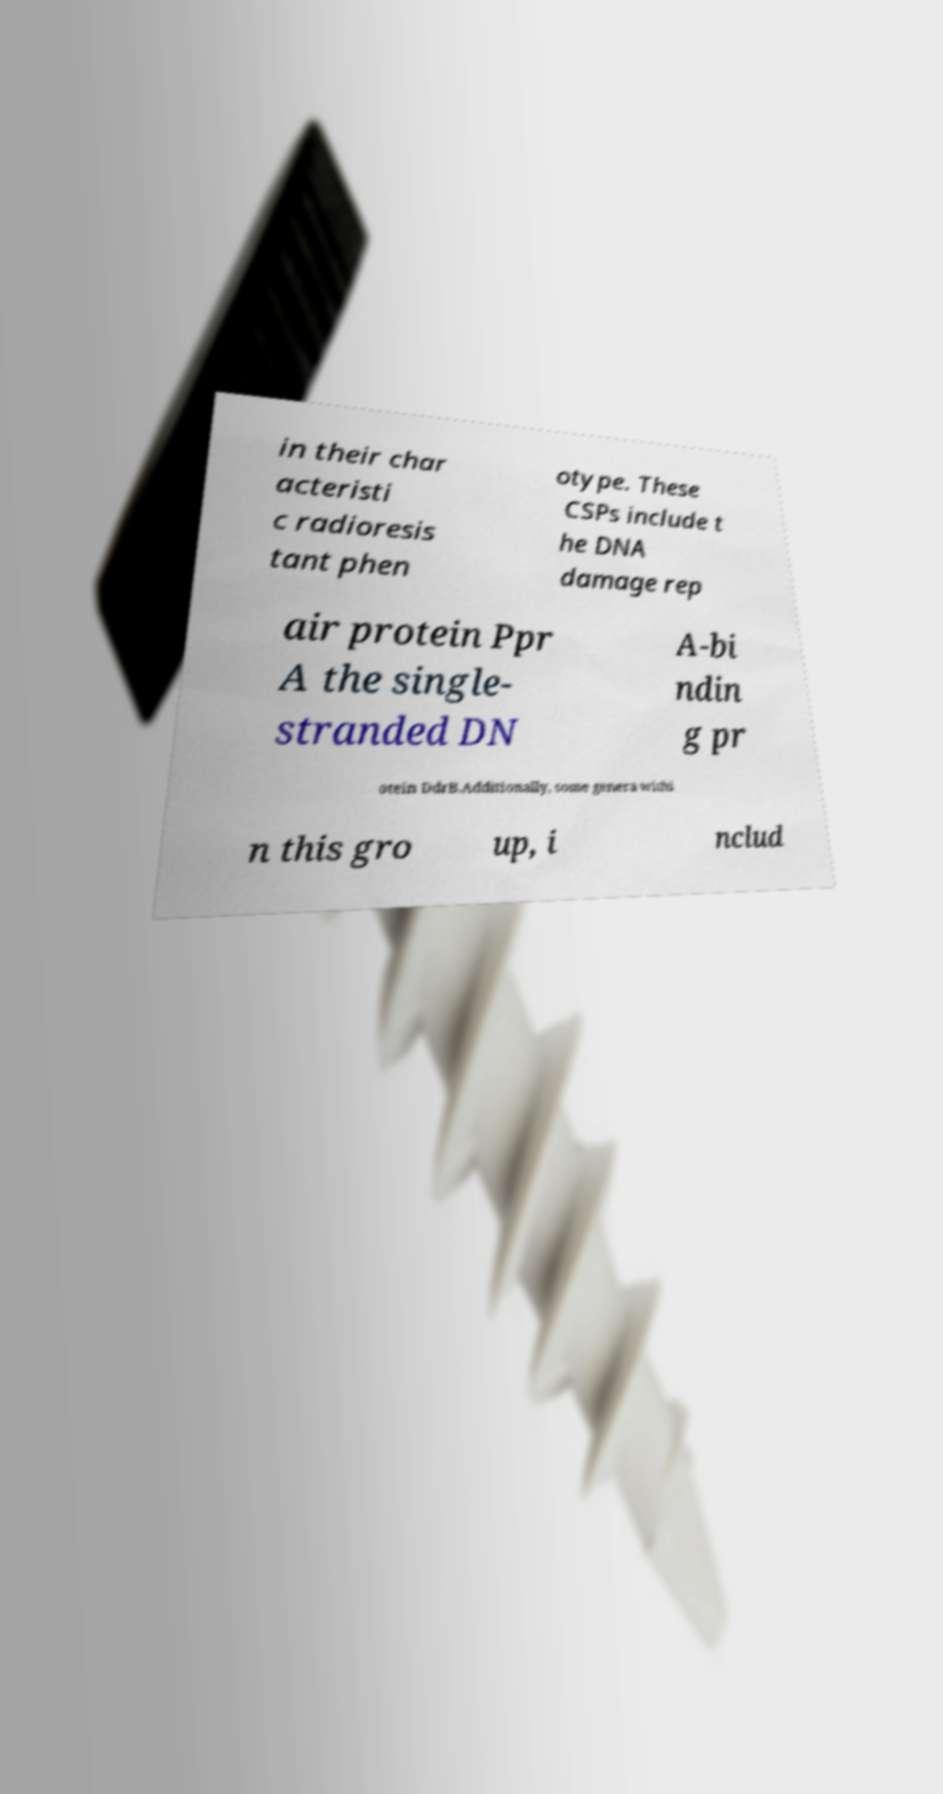What messages or text are displayed in this image? I need them in a readable, typed format. in their char acteristi c radioresis tant phen otype. These CSPs include t he DNA damage rep air protein Ppr A the single- stranded DN A-bi ndin g pr otein DdrB.Additionally, some genera withi n this gro up, i nclud 